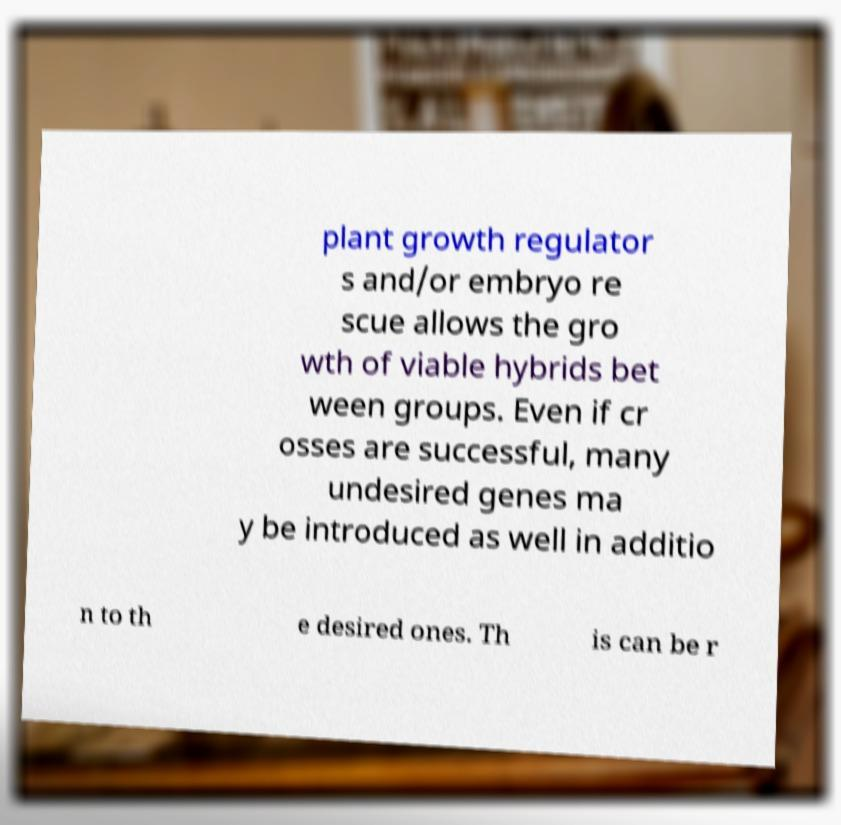Please identify and transcribe the text found in this image. plant growth regulator s and/or embryo re scue allows the gro wth of viable hybrids bet ween groups. Even if cr osses are successful, many undesired genes ma y be introduced as well in additio n to th e desired ones. Th is can be r 